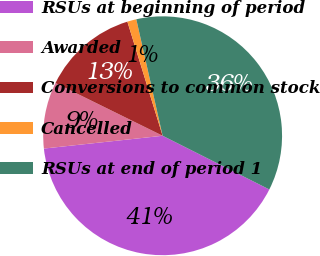Convert chart. <chart><loc_0><loc_0><loc_500><loc_500><pie_chart><fcel>RSUs at beginning of period<fcel>Awarded<fcel>Conversions to common stock<fcel>Cancelled<fcel>RSUs at end of period 1<nl><fcel>40.87%<fcel>8.99%<fcel>12.95%<fcel>1.23%<fcel>35.96%<nl></chart> 